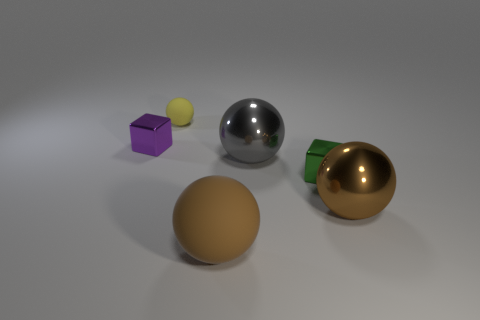What could be the purpose of the yellow sphere? The yellow sphere may serve an aesthetic purpose in this context, potentially functioning as a decorative element or as part of a set for illustrative or educational use. Its presence could also be intended for color contrast and compositional balance in the image. 